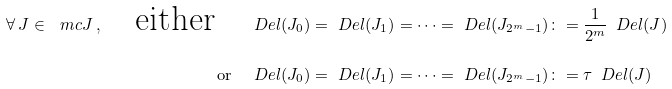<formula> <loc_0><loc_0><loc_500><loc_500>\forall \, J \in \ m c J \, , \quad \text {either} \quad & \ D e l ( J _ { 0 } ) = \ D e l ( J _ { 1 } ) = \dots = \ D e l ( J _ { 2 ^ { m } - 1 } ) \colon = \frac { 1 } { 2 ^ { m } } \, \ D e l ( J ) \\ \quad \text {or} \quad & \ D e l ( J _ { 0 } ) = \ D e l ( J _ { 1 } ) = \dots = \ D e l ( J _ { 2 ^ { m } - 1 } ) \colon = \tau \, \ D e l ( J )</formula> 